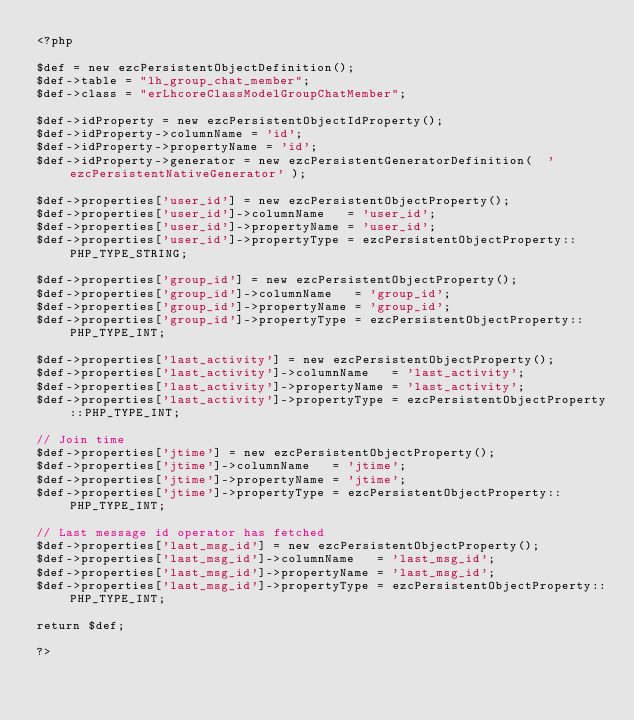Convert code to text. <code><loc_0><loc_0><loc_500><loc_500><_PHP_><?php

$def = new ezcPersistentObjectDefinition();
$def->table = "lh_group_chat_member";
$def->class = "erLhcoreClassModelGroupChatMember";

$def->idProperty = new ezcPersistentObjectIdProperty();
$def->idProperty->columnName = 'id';
$def->idProperty->propertyName = 'id';
$def->idProperty->generator = new ezcPersistentGeneratorDefinition(  'ezcPersistentNativeGenerator' );

$def->properties['user_id'] = new ezcPersistentObjectProperty();
$def->properties['user_id']->columnName   = 'user_id';
$def->properties['user_id']->propertyName = 'user_id';
$def->properties['user_id']->propertyType = ezcPersistentObjectProperty::PHP_TYPE_STRING;

$def->properties['group_id'] = new ezcPersistentObjectProperty();
$def->properties['group_id']->columnName   = 'group_id';
$def->properties['group_id']->propertyName = 'group_id';
$def->properties['group_id']->propertyType = ezcPersistentObjectProperty::PHP_TYPE_INT;

$def->properties['last_activity'] = new ezcPersistentObjectProperty();
$def->properties['last_activity']->columnName   = 'last_activity';
$def->properties['last_activity']->propertyName = 'last_activity';
$def->properties['last_activity']->propertyType = ezcPersistentObjectProperty::PHP_TYPE_INT;

// Join time
$def->properties['jtime'] = new ezcPersistentObjectProperty();
$def->properties['jtime']->columnName   = 'jtime';
$def->properties['jtime']->propertyName = 'jtime';
$def->properties['jtime']->propertyType = ezcPersistentObjectProperty::PHP_TYPE_INT;

// Last message id operator has fetched
$def->properties['last_msg_id'] = new ezcPersistentObjectProperty();
$def->properties['last_msg_id']->columnName   = 'last_msg_id';
$def->properties['last_msg_id']->propertyName = 'last_msg_id';
$def->properties['last_msg_id']->propertyType = ezcPersistentObjectProperty::PHP_TYPE_INT;

return $def;

?></code> 